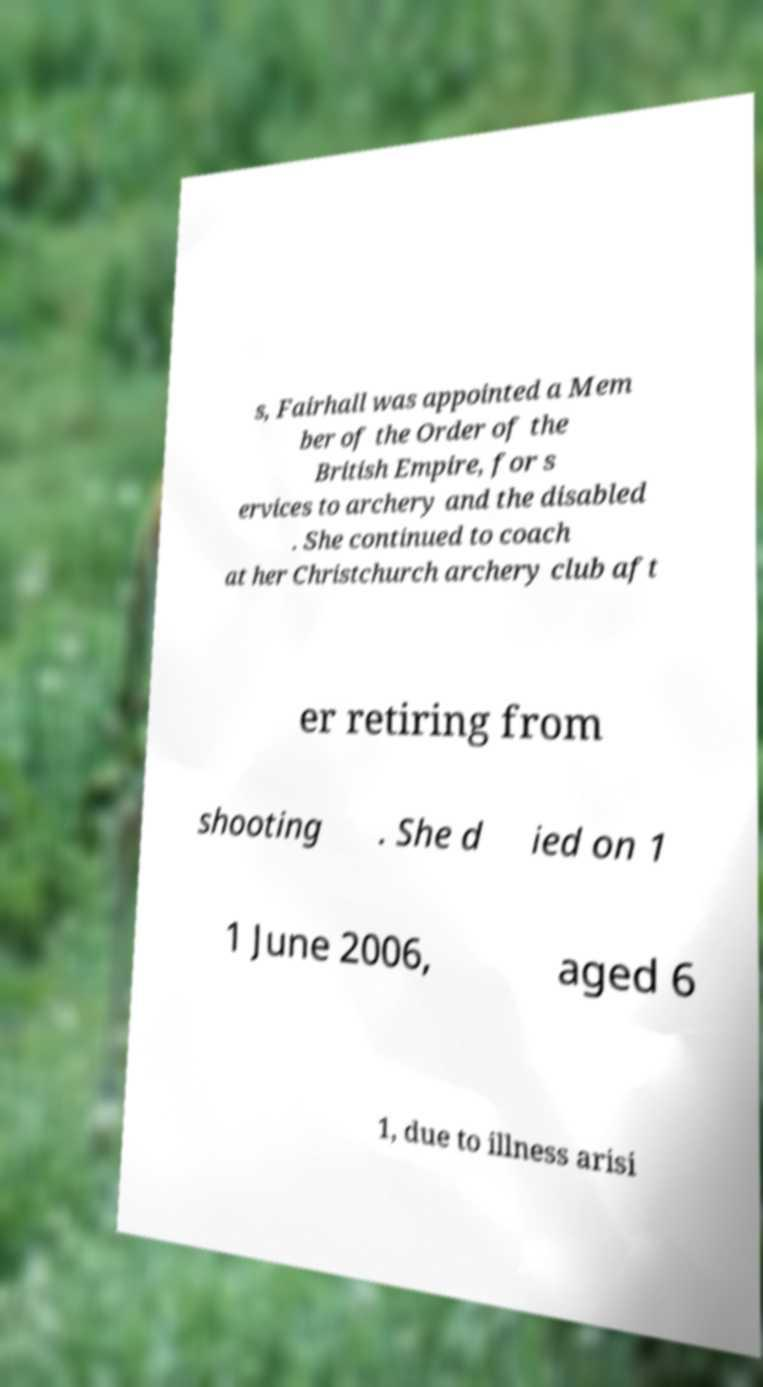There's text embedded in this image that I need extracted. Can you transcribe it verbatim? s, Fairhall was appointed a Mem ber of the Order of the British Empire, for s ervices to archery and the disabled . She continued to coach at her Christchurch archery club aft er retiring from shooting . She d ied on 1 1 June 2006, aged 6 1, due to illness arisi 